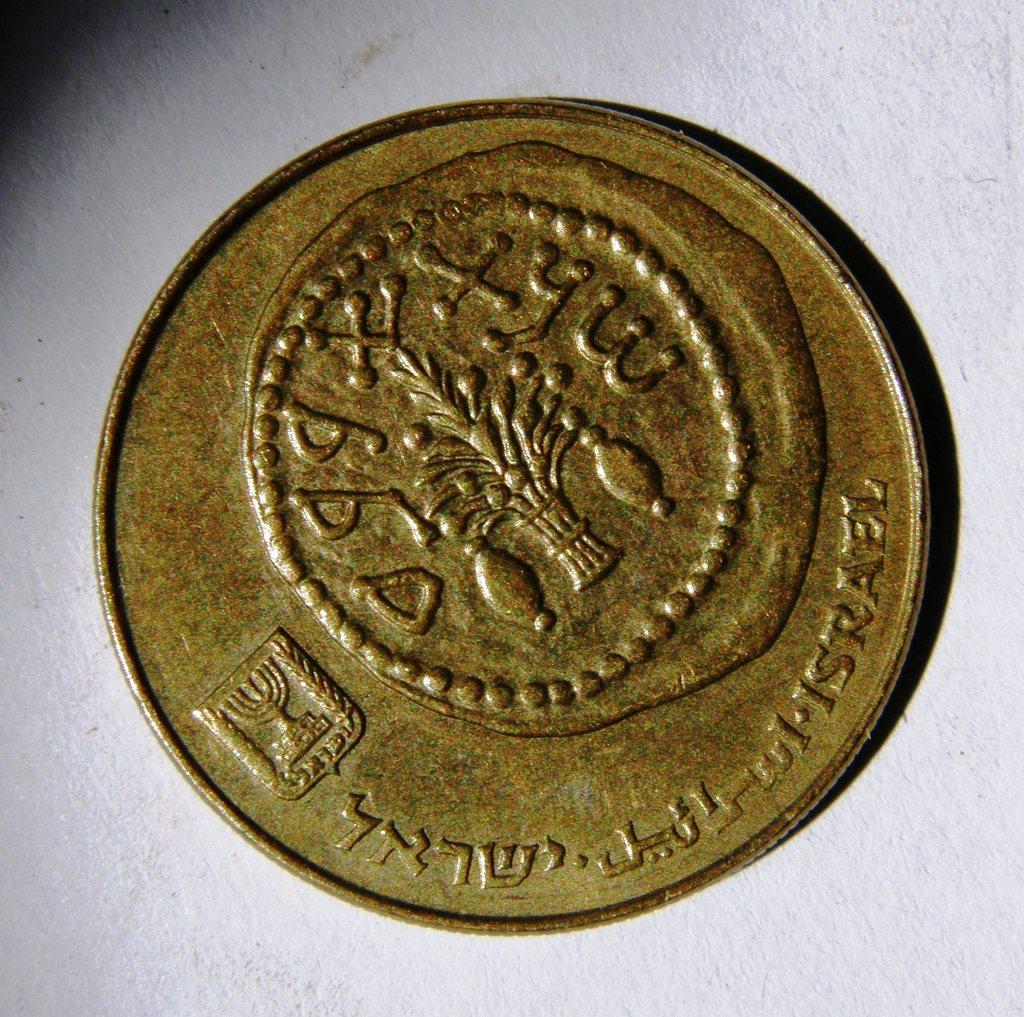<image>
Share a concise interpretation of the image provided. A gold coin with a tree imprinted in the middle of it that reads Isreal on the side 